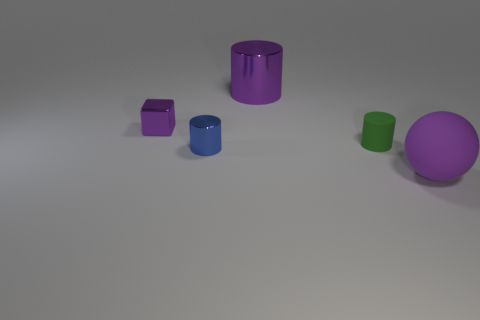Add 4 metallic cubes. How many objects exist? 9 Subtract all cylinders. How many objects are left? 2 Subtract all rubber things. Subtract all shiny objects. How many objects are left? 0 Add 1 tiny purple metal things. How many tiny purple metal things are left? 2 Add 5 tiny brown cylinders. How many tiny brown cylinders exist? 5 Subtract 1 blue cylinders. How many objects are left? 4 